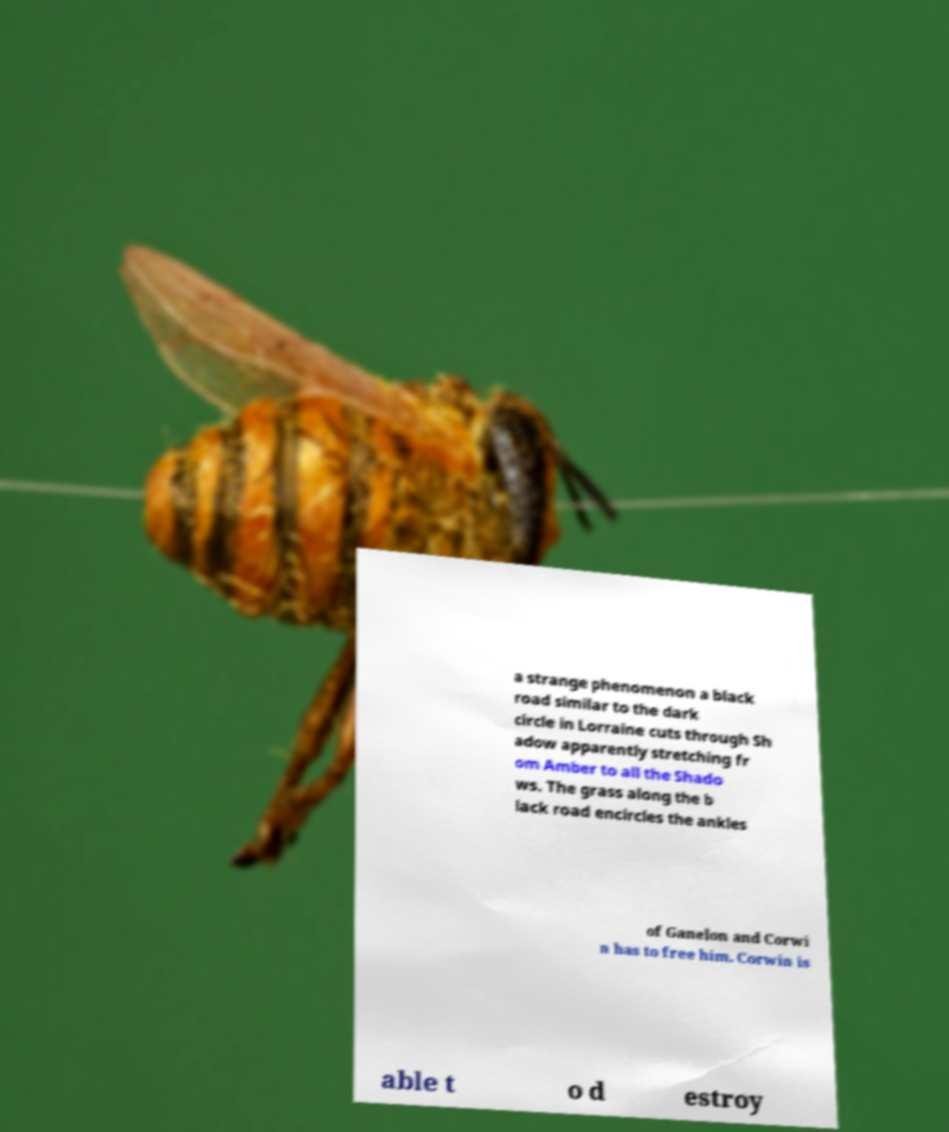There's text embedded in this image that I need extracted. Can you transcribe it verbatim? a strange phenomenon a black road similar to the dark circle in Lorraine cuts through Sh adow apparently stretching fr om Amber to all the Shado ws. The grass along the b lack road encircles the ankles of Ganelon and Corwi n has to free him. Corwin is able t o d estroy 